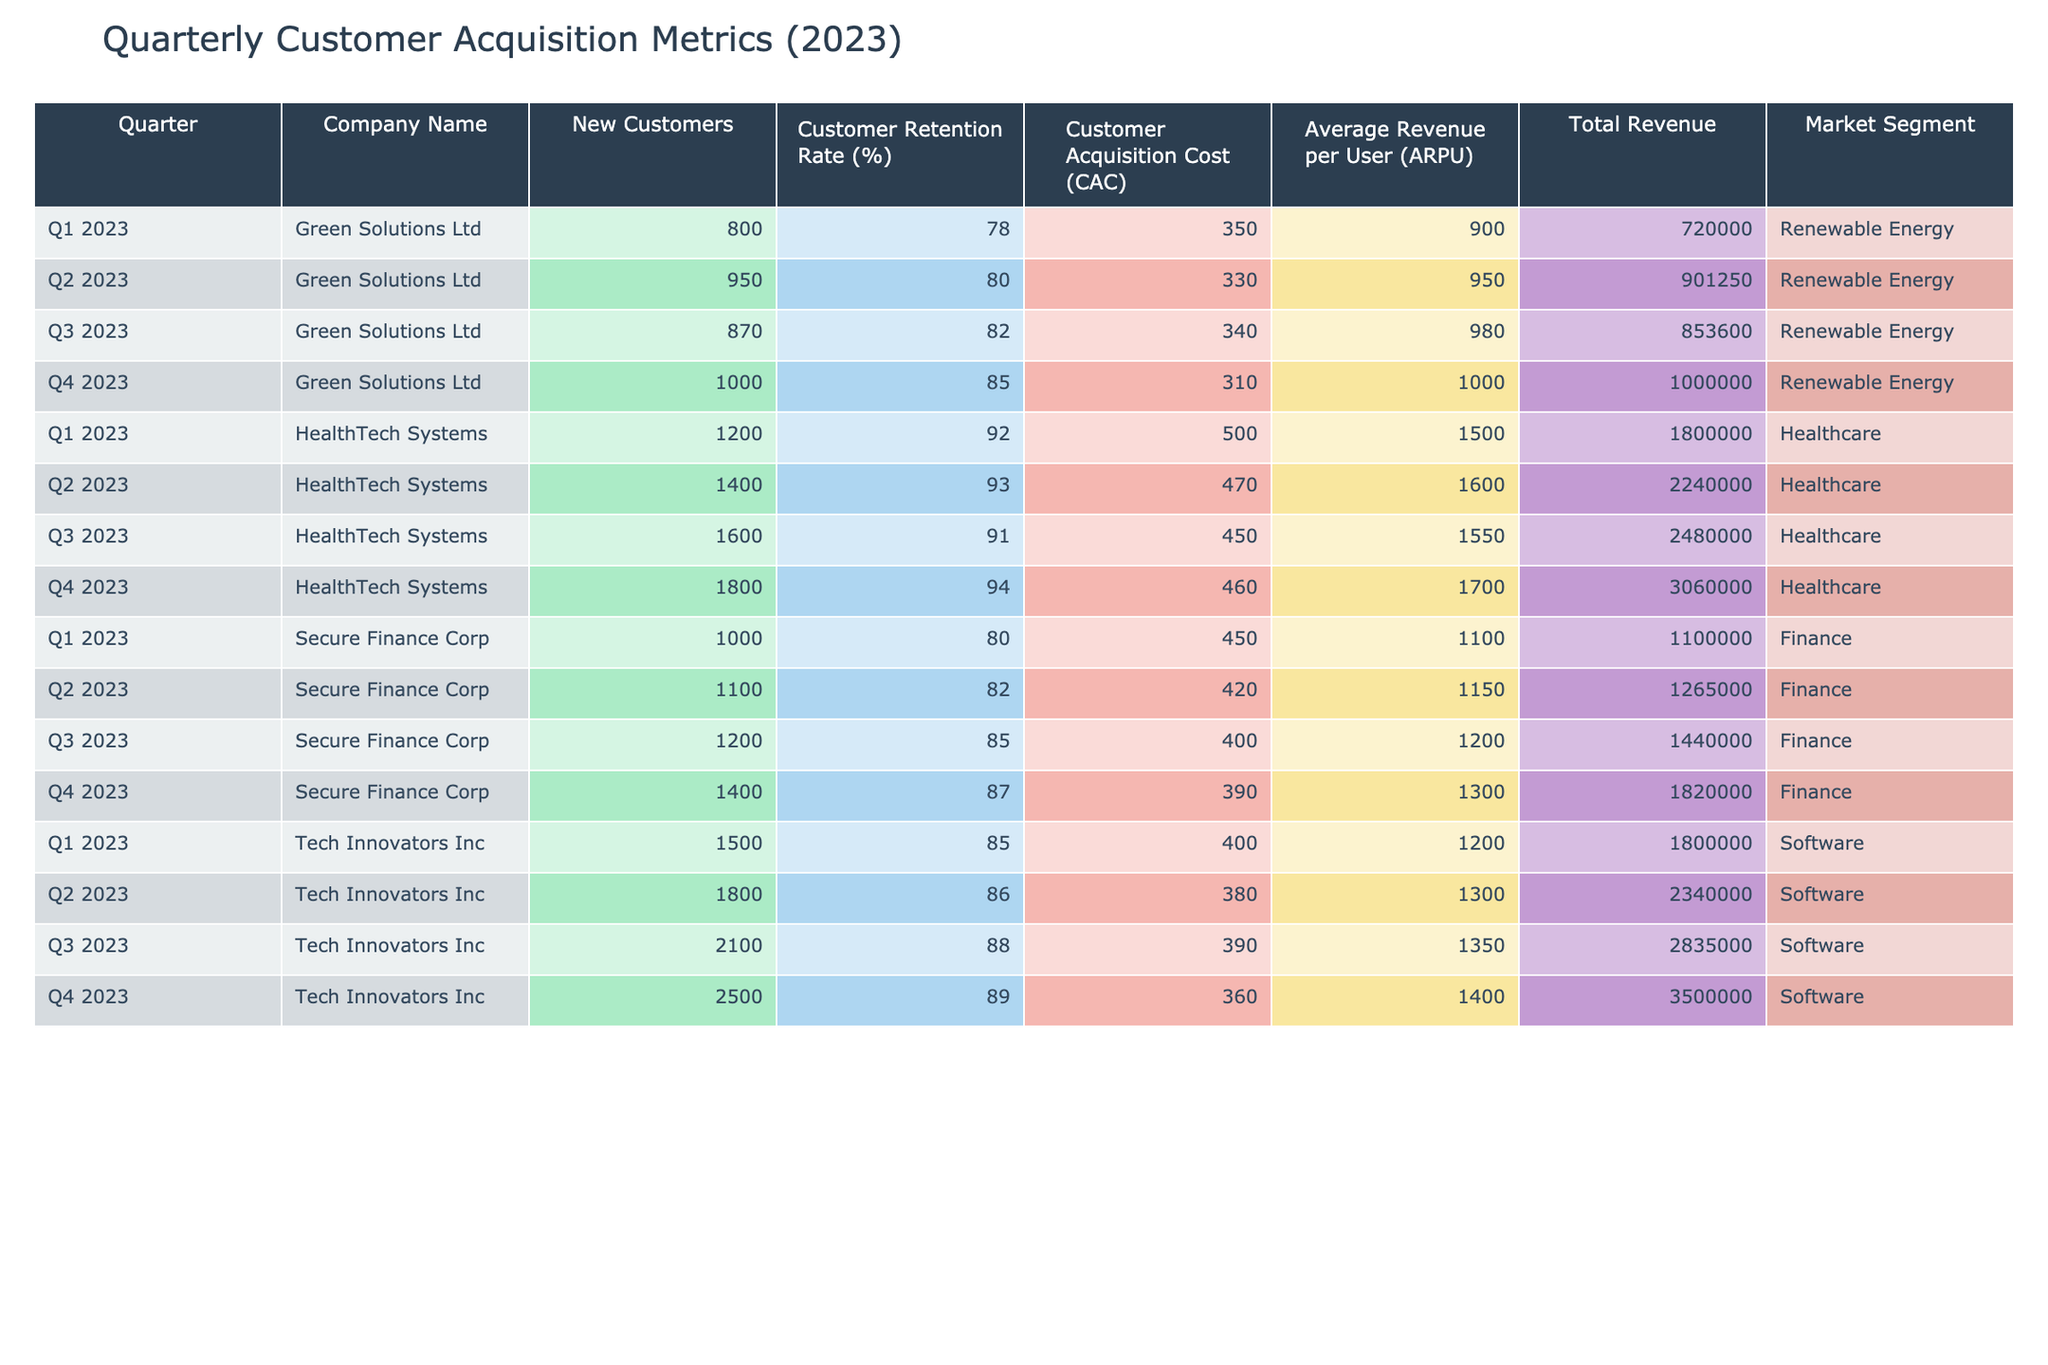What was the Customer Acquisition Cost for HealthTech Systems in Q3 2023? The table shows that for HealthTech Systems in Q3 2023, the Customer Acquisition Cost (CAC) is listed as 450.
Answer: 450 Which company had the highest Total Revenue in Q2 2023? In Q2 2023, Tech Innovators Inc had a Total Revenue of 2,340,000, which is higher than the other companies listed in that quarter.
Answer: Tech Innovators Inc What is the average Customer Retention Rate across all companies in Q4 2023? To find the average, we take the sum of the Customer Retention Rates for Q4 2023 (89 + 85 + 94 + 87 = 355) and divide by the total number of companies (4), resulting in 355/4 = 88.75.
Answer: 88.75 Did Green Solutions Ltd improve their Customer Retention Rate from Q1 to Q4 2023? The Customer Retention Rate for Green Solutions Ltd in Q1 2023 was 78%, while in Q4 2023, it increased to 85%. This shows an improvement.
Answer: Yes Which market segment has the highest average ARPU across all quarters? The ARPU for Software is 1200 (Q1) + 1300 (Q2) + 1350 (Q3) + 1400 (Q4) = 5150; for Renewable Energy it is 900 + 950 + 980 + 1000 = 3830; for Healthcare it is 1500 + 1600 + 1550 + 1700 = 6350; and for Finance it is 1100 + 1150 + 1200 + 1300 = 4550. The highest sum is 6350 for Healthcare, leading to an average of 1587.5.
Answer: Healthcare How many new customers did Secure Finance Corp gain in total throughout 2023? The New Customers for Secure Finance Corp across all quarters are 1000 (Q1) + 1100 (Q2) + 1200 (Q3) + 1400 (Q4) = 3700.
Answer: 3700 What was the difference in Total Revenue between Tech Innovators Inc in Q1 and Q4 2023? The Total Revenue for Tech Innovators Inc in Q1 2023 is 1,800,000 and in Q4 2023 is 3,500,000. The difference is 3,500,000 - 1,800,000 = 1,700,000.
Answer: 1,700,000 For which company was the Customer Acquisition Cost (CAC) the lowest in Q2 2023? In Q2 2023, the CAC values are listed as 380 (Tech Innovators), 330 (Green Solutions), 470 (HealthTech Systems), and 420 (Secure Finance). The lowest is 330 for Green Solutions.
Answer: Green Solutions Ltd How did the Number of New Customers change for HealthTech Systems from Q1 to Q3 2023? HealthTech Systems gained 1200 new customers in Q1 and 1600 in Q3. The change is 1600 - 1200 = 400 more customers in Q3.
Answer: Increased by 400 Which company had the highest Customer Acquisition Cost in Q1 2023? The CAC values for Q1 2023 are 400 (Tech Innovators), 350 (Green Solutions), 500 (HealthTech), and 450 (Secure Finance). The highest is 500 for HealthTech Systems.
Answer: HealthTech Systems 